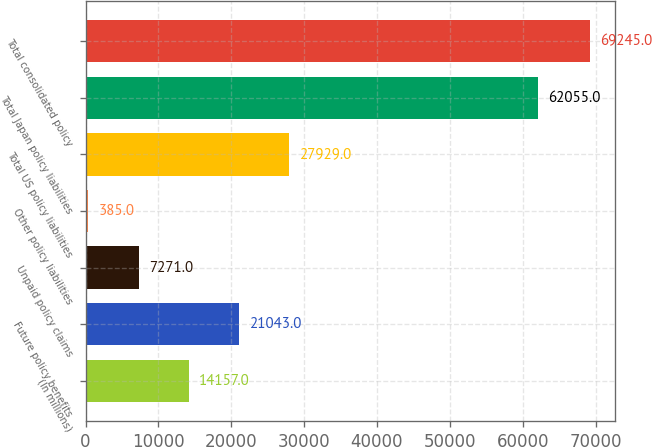Convert chart to OTSL. <chart><loc_0><loc_0><loc_500><loc_500><bar_chart><fcel>(In millions)<fcel>Future policy benefits<fcel>Unpaid policy claims<fcel>Other policy liabilities<fcel>Total US policy liabilities<fcel>Total Japan policy liabilities<fcel>Total consolidated policy<nl><fcel>14157<fcel>21043<fcel>7271<fcel>385<fcel>27929<fcel>62055<fcel>69245<nl></chart> 